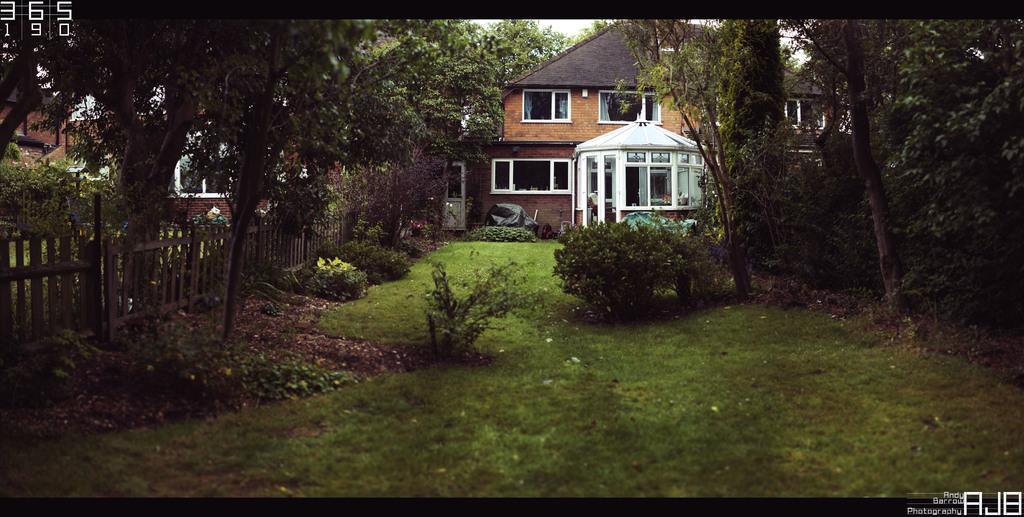Please provide a concise description of this image. In the center of the image we can see buildings with windows, door, roofs. The two covers are placed on the ground. On the left side of the image we can see a fence. In the background, we can see grass, a group of trees, plants, the sky and some text. 